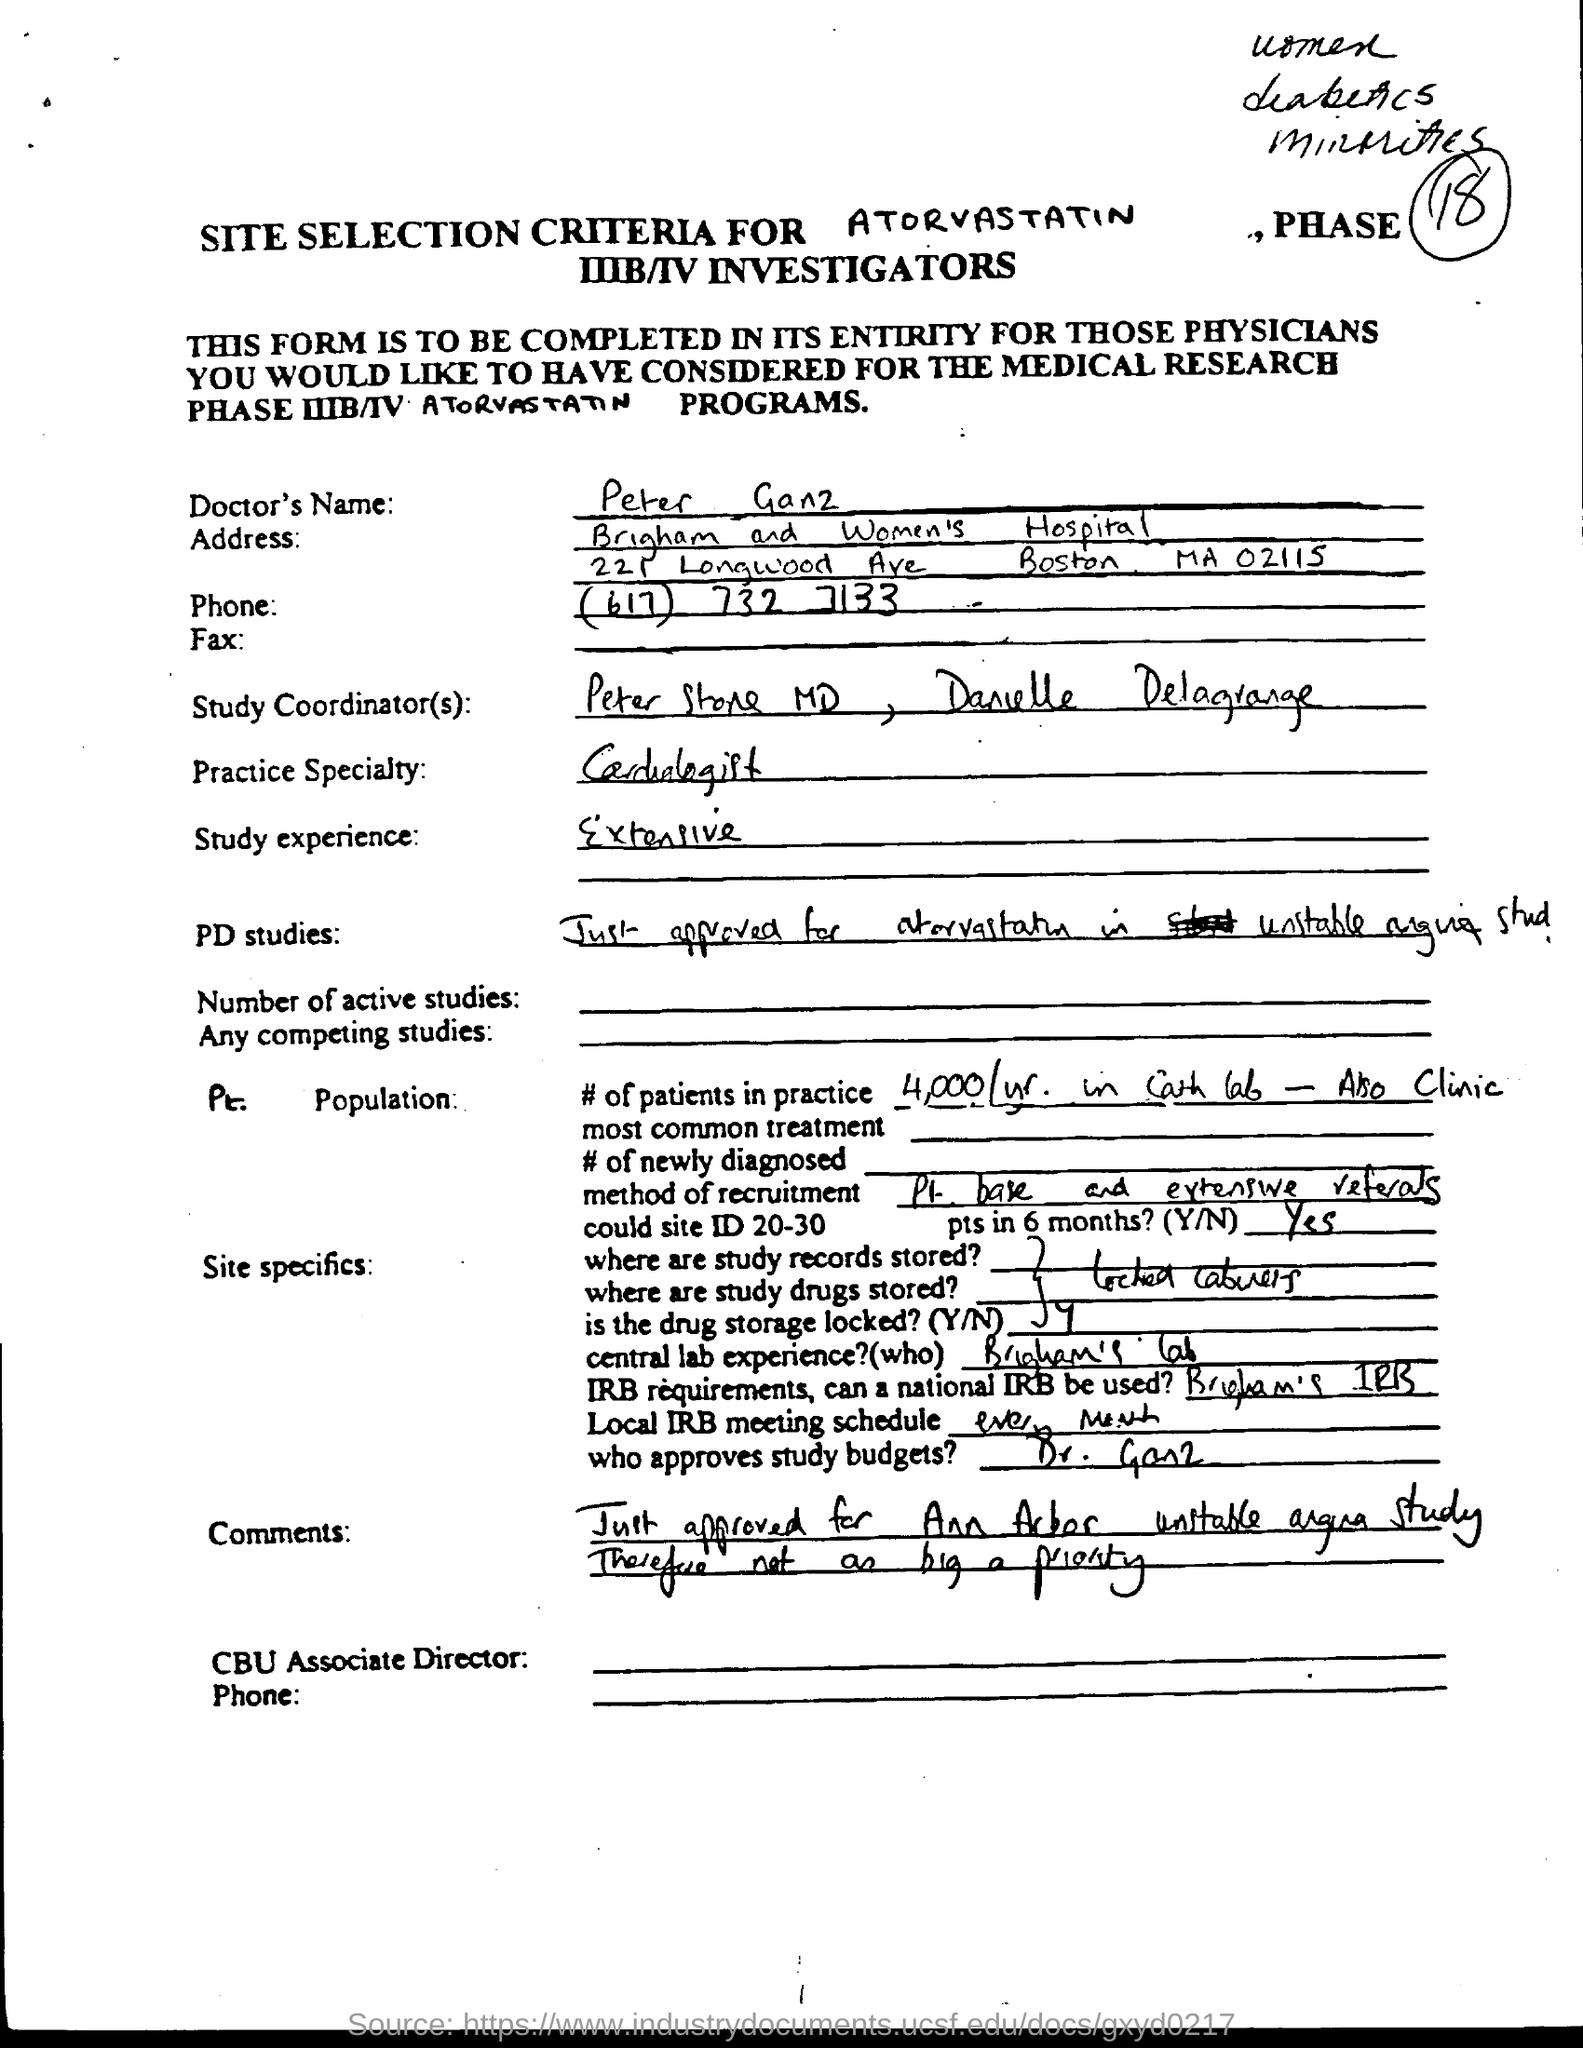Identify some key points in this picture. The Doctor's practice specializes in cardiology. The Doctor's study experience is extensive. The doctor's name is Peter Ganz. 